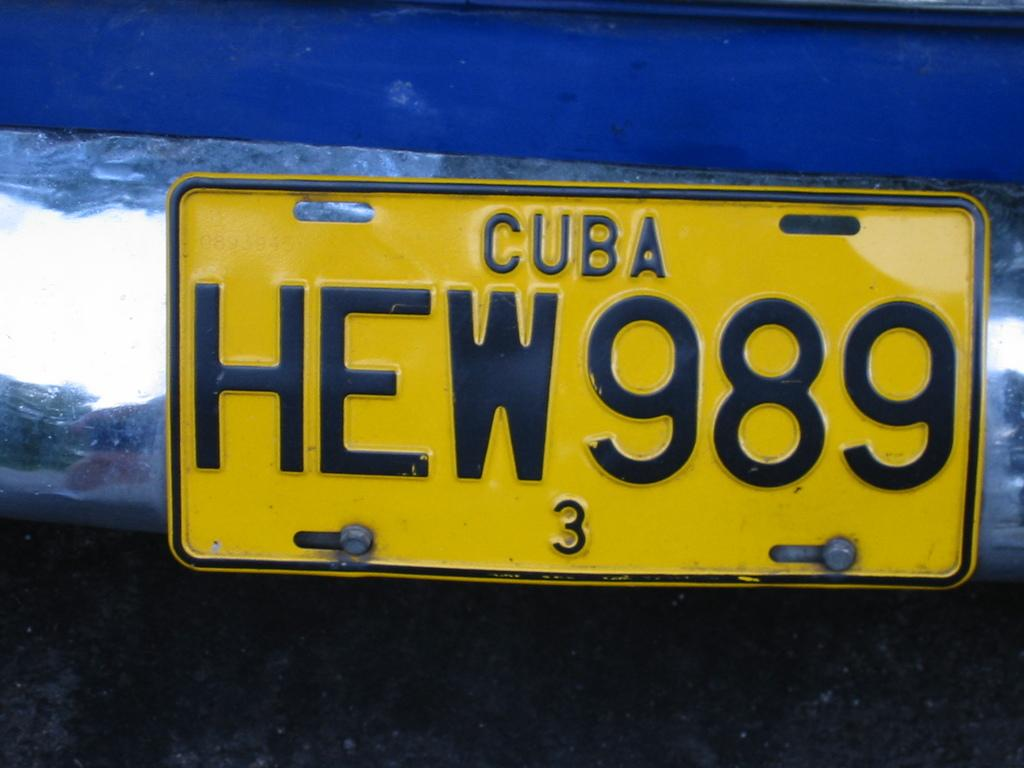<image>
Describe the image concisely. a cuba license plate on a car that is yellow 